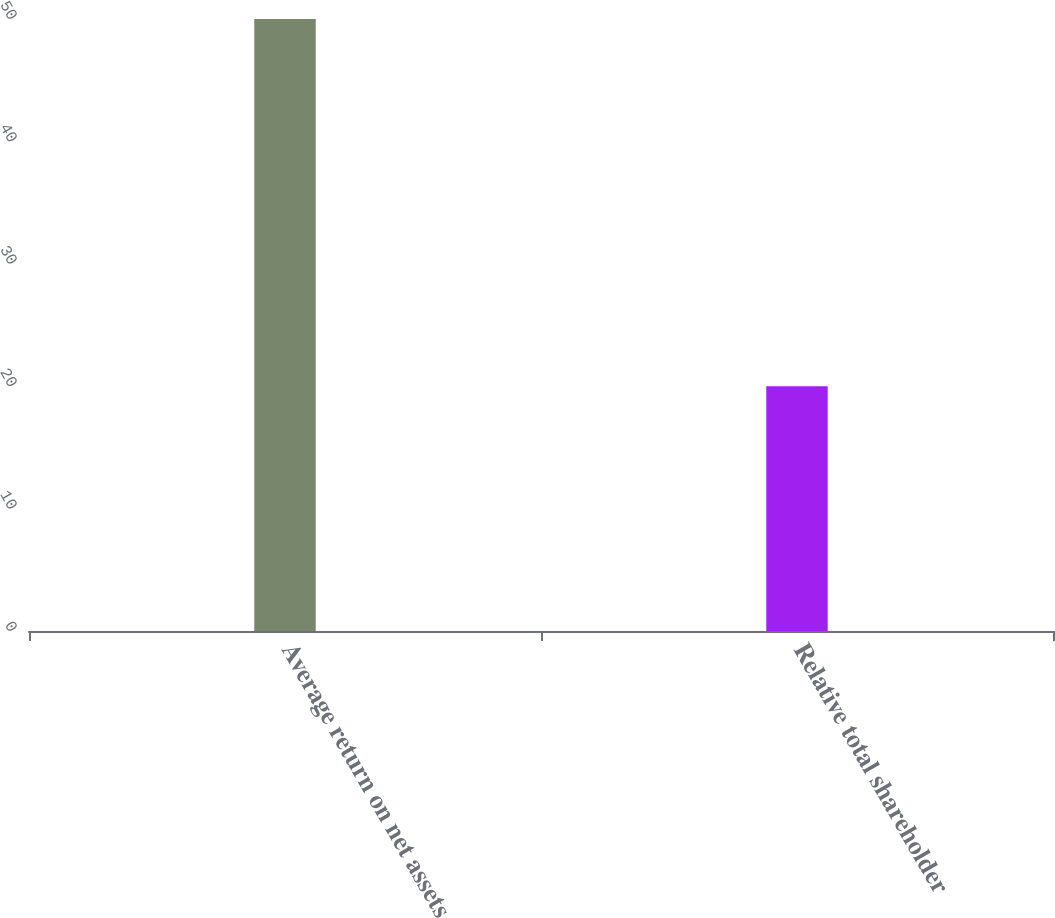Convert chart to OTSL. <chart><loc_0><loc_0><loc_500><loc_500><bar_chart><fcel>Average return on net assets<fcel>Relative total shareholder<nl><fcel>50<fcel>20<nl></chart> 